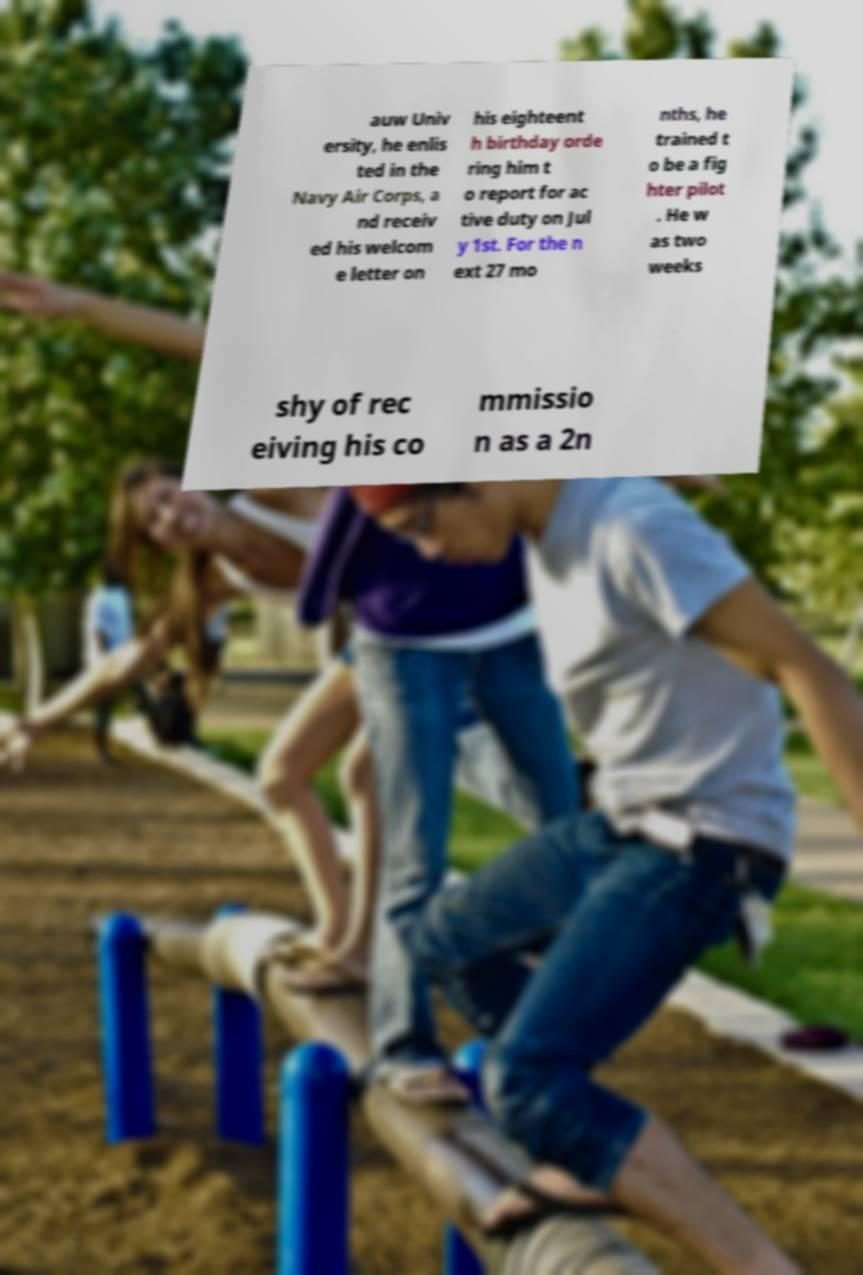Please identify and transcribe the text found in this image. auw Univ ersity, he enlis ted in the Navy Air Corps, a nd receiv ed his welcom e letter on his eighteent h birthday orde ring him t o report for ac tive duty on Jul y 1st. For the n ext 27 mo nths, he trained t o be a fig hter pilot . He w as two weeks shy of rec eiving his co mmissio n as a 2n 